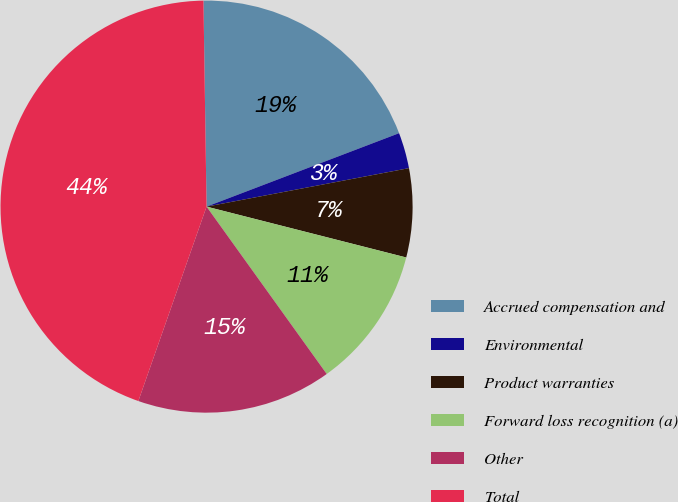Convert chart. <chart><loc_0><loc_0><loc_500><loc_500><pie_chart><fcel>Accrued compensation and<fcel>Environmental<fcel>Product warranties<fcel>Forward loss recognition (a)<fcel>Other<fcel>Total<nl><fcel>19.44%<fcel>2.81%<fcel>6.96%<fcel>11.12%<fcel>15.28%<fcel>44.39%<nl></chart> 